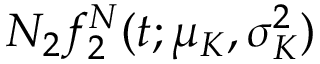Convert formula to latex. <formula><loc_0><loc_0><loc_500><loc_500>N _ { 2 } f _ { 2 } ^ { N } ( t ; \mu _ { K } , \sigma _ { K } ^ { 2 } )</formula> 